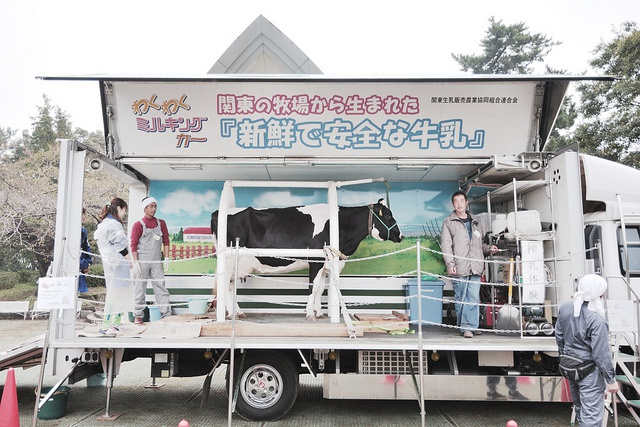Describe the objects in this image and their specific colors. I can see truck in white, lightgray, darkgray, black, and gray tones, cow in white, black, lightgray, gray, and darkgray tones, people in white, darkgray, lightgray, and gray tones, people in white, darkgray, lightgray, and gray tones, and people in white, lightgray, darkgray, and gray tones in this image. 